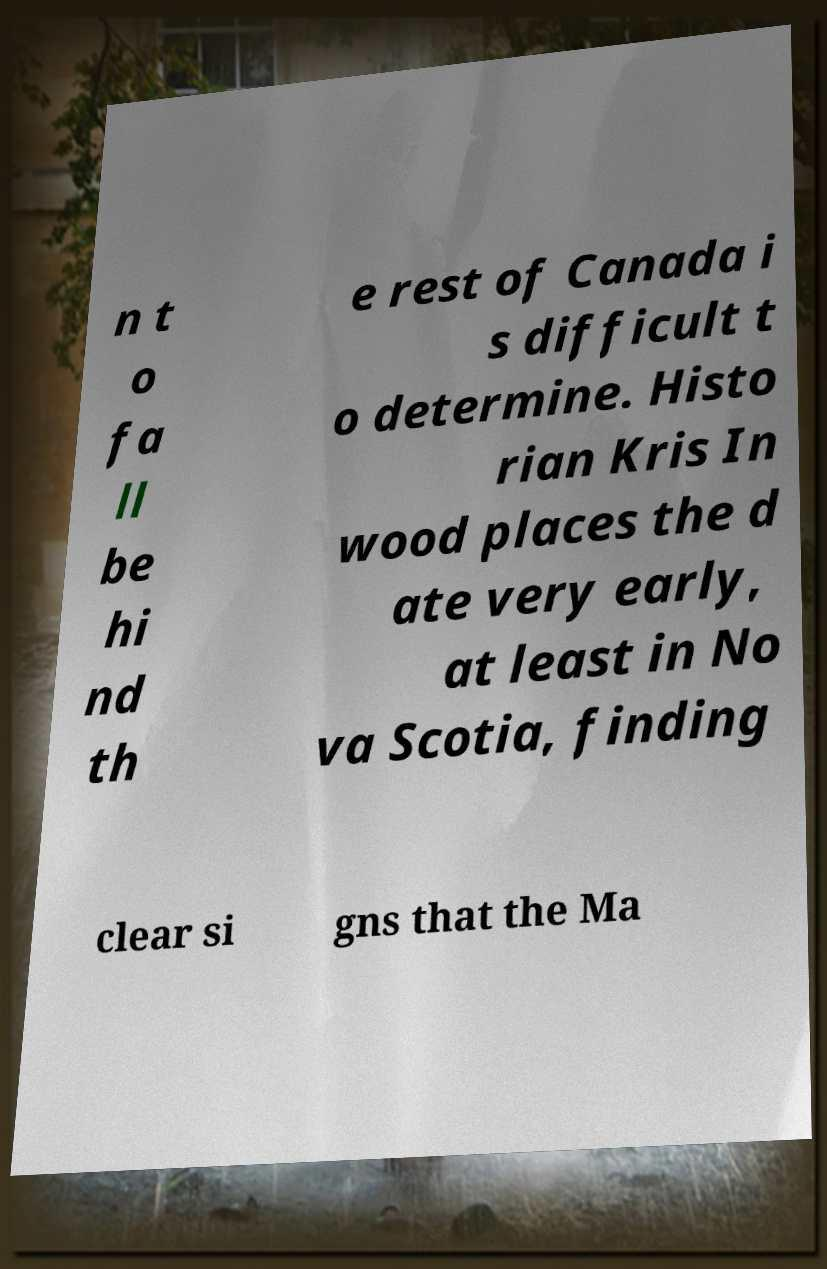Can you read and provide the text displayed in the image?This photo seems to have some interesting text. Can you extract and type it out for me? n t o fa ll be hi nd th e rest of Canada i s difficult t o determine. Histo rian Kris In wood places the d ate very early, at least in No va Scotia, finding clear si gns that the Ma 